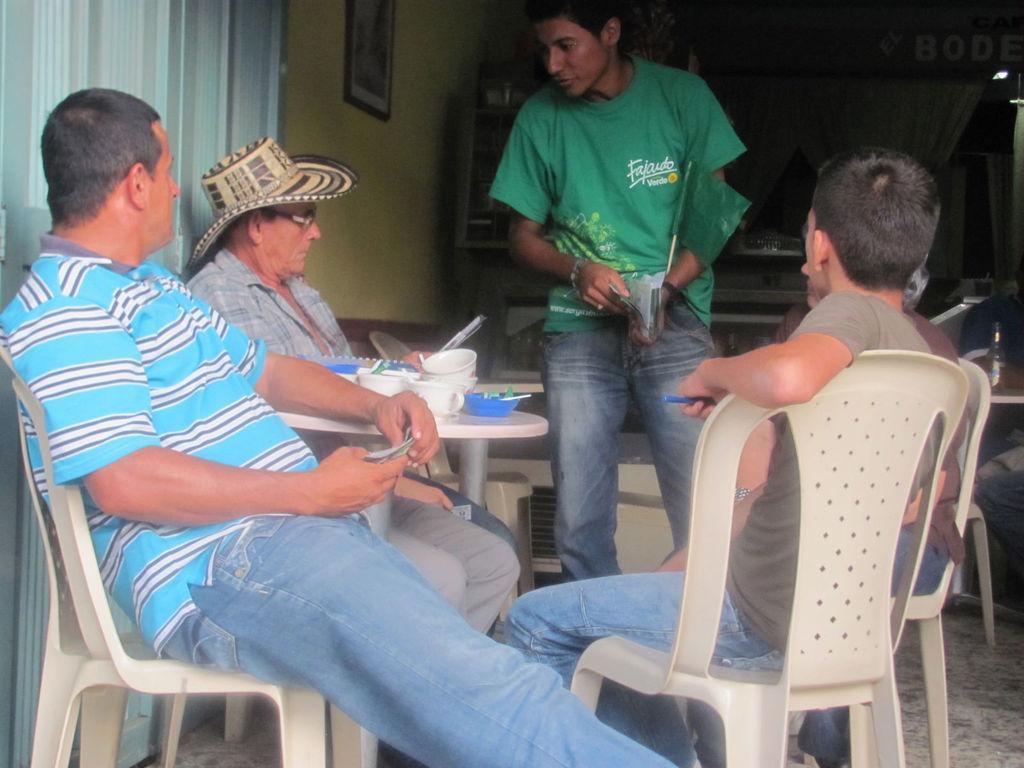Please provide a concise description of this image. In the image there is a table. There are people sitting around the table. The man in the green shirt is standing and holding some papers in his hand. There are cups, bowls and some plates plates placed on the table. In the background there is a curtain, a wall and a door 